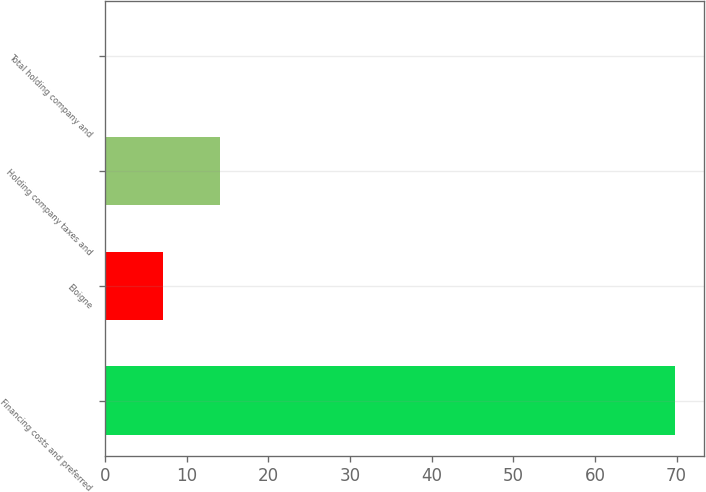Convert chart. <chart><loc_0><loc_0><loc_500><loc_500><bar_chart><fcel>Financing costs and preferred<fcel>Eloigne<fcel>Holding company taxes and<fcel>Total holding company and<nl><fcel>69.86<fcel>7.1<fcel>14.06<fcel>0.14<nl></chart> 